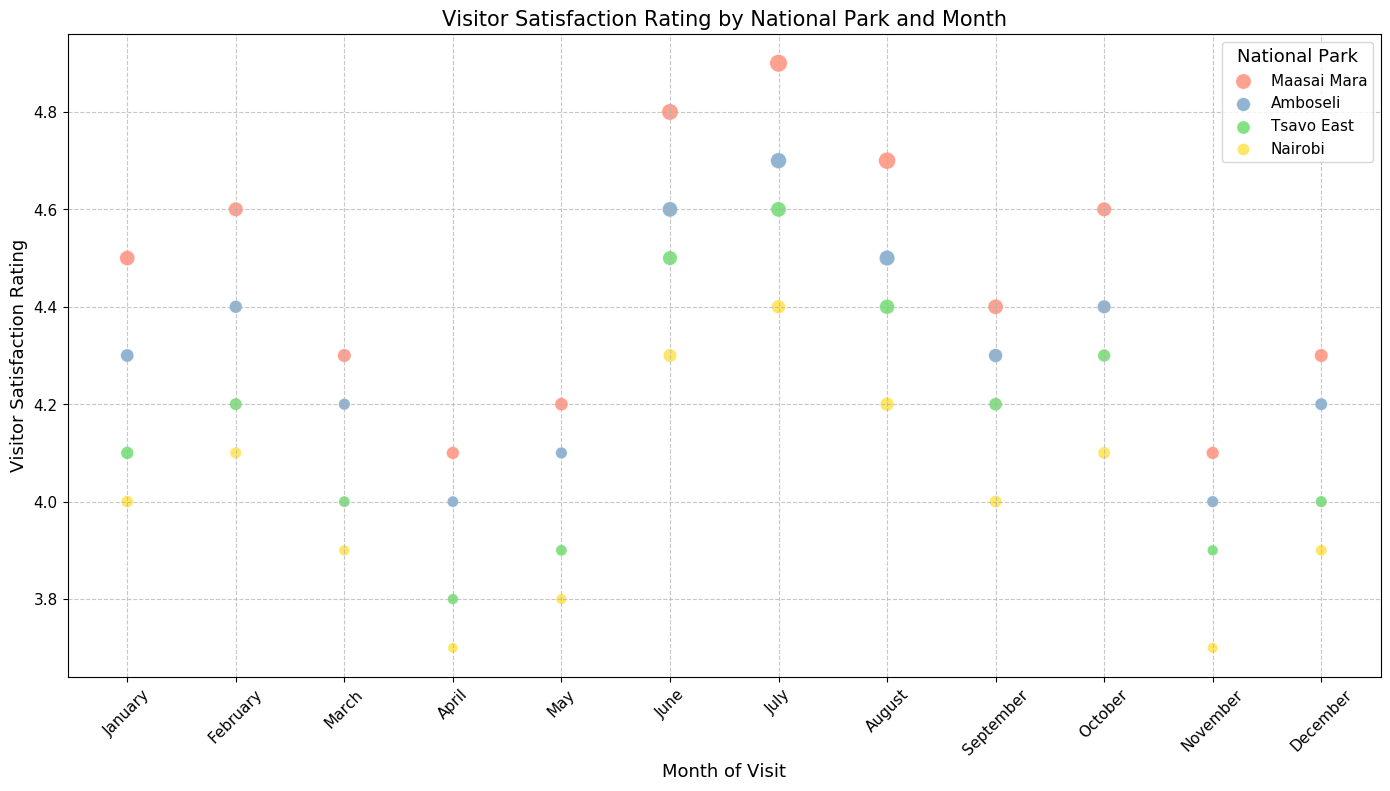What is the highest visitor satisfaction rating across all parks and months? Look for the highest point on the vertical axis (Visitor Satisfaction Rating) for all parks. The highest rating is 4.9 in July for Maasai Mara.
Answer: 4.9 Which month sees the highest number of visitors in Maasai Mara, and what is the corresponding satisfaction rating? Look for the largest bubble in the Maasai Mara color in each month. The largest bubble is observed in July, corresponding to a rating of 4.9.
Answer: July, 4.9 Comparing the visitor satisfaction ratings in July, which park has the lowest rating and what is it? Look for the points on the chart located in July for each park and identify the one with the lowest vertical position. Nairobi has the lowest rating of 4.4.
Answer: Nairobi, 4.4 Which park and month combination shows the lowest visitor satisfaction rating? Identify the lowest point on the vertical axis (Visitor Satisfaction Rating). Nairobi in April has the lowest rating of 3.7.
Answer: Nairobi, April What is the average visitor satisfaction rating in December across all parks? Find all points corresponding to December and calculate the mean of their vertical positions. The ratings are 4.3, 4.2, 4.0, and 3.9. Average is (4.3 + 4.2 + 4.0 + 3.9) / 4 = 4.1.
Answer: 4.1 Which month has the most visitors overall, and what can you infer about the satisfaction ratings for that month? Identify the month with the largest cumulative bubble size across parks. July has the most visitors overall. Ratings in July are: Maasai Mara (4.9), Amboseli (4.7), Tsavo East (4.6), Nairobi (4.4). On average, these ratings are high, indicating high satisfaction.
Answer: July Do visitor satisfaction ratings generally tend to be higher in months with more visitors? Compare the sizes and vertical positions of bubbles. Larger bubbles (more visitors) largely correspond with higher satisfaction ratings, especially for months like July and June.
Answer: Yes Compare visitor satisfaction ratings between Maasai Mara and Nairobi in February. Which park has higher satisfaction and by how much? Locate ratings for both parks in February and compare their vertical positions. Maasai Mara has a rating of 4.6, while Nairobi has 4.1. Maasai Mara's satisfaction is higher by 0.5.
Answer: Maasai Mara by 0.5 